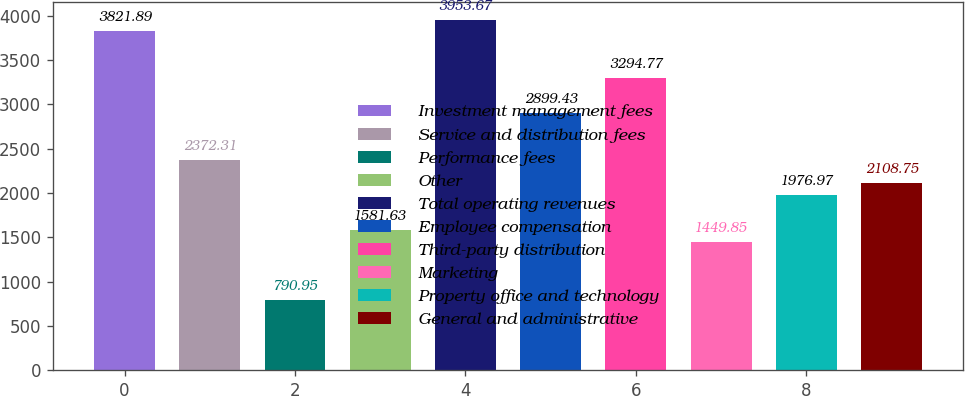Convert chart to OTSL. <chart><loc_0><loc_0><loc_500><loc_500><bar_chart><fcel>Investment management fees<fcel>Service and distribution fees<fcel>Performance fees<fcel>Other<fcel>Total operating revenues<fcel>Employee compensation<fcel>Third-party distribution<fcel>Marketing<fcel>Property office and technology<fcel>General and administrative<nl><fcel>3821.89<fcel>2372.31<fcel>790.95<fcel>1581.63<fcel>3953.67<fcel>2899.43<fcel>3294.77<fcel>1449.85<fcel>1976.97<fcel>2108.75<nl></chart> 